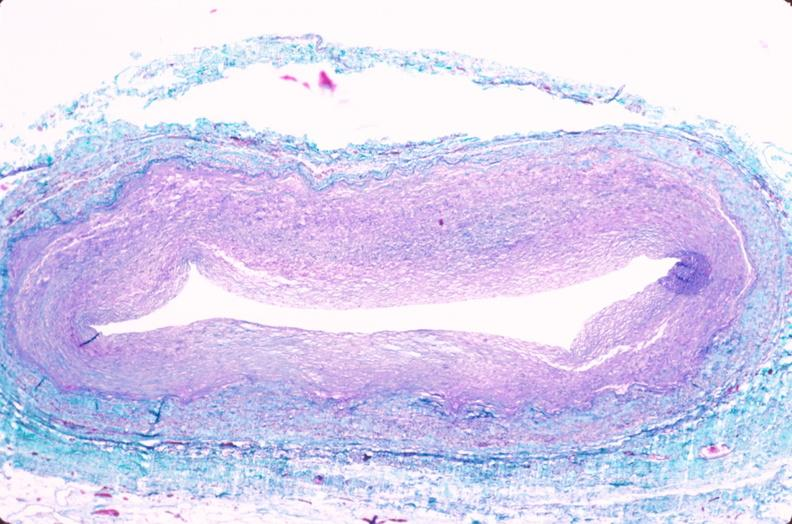where is this in?
Answer the question using a single word or phrase. In vasculature 